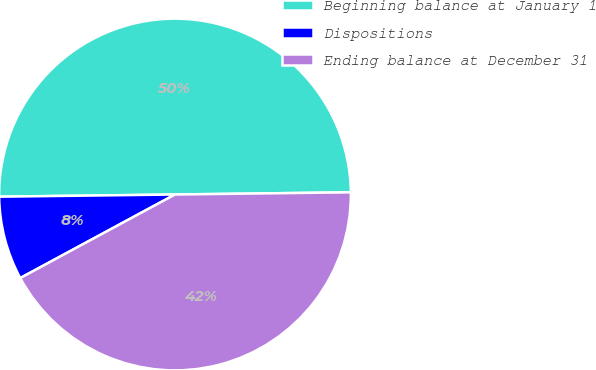<chart> <loc_0><loc_0><loc_500><loc_500><pie_chart><fcel>Beginning balance at January 1<fcel>Dispositions<fcel>Ending balance at December 31<nl><fcel>50.0%<fcel>7.68%<fcel>42.32%<nl></chart> 